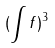<formula> <loc_0><loc_0><loc_500><loc_500>( \int f ) ^ { 3 }</formula> 